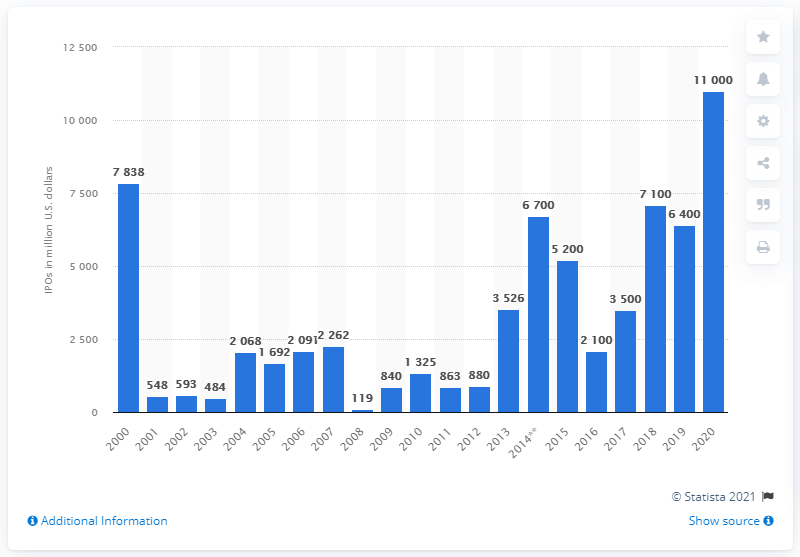Outline some significant characteristics in this image. In 2018, the amount of IPOs raised was 7,100... 